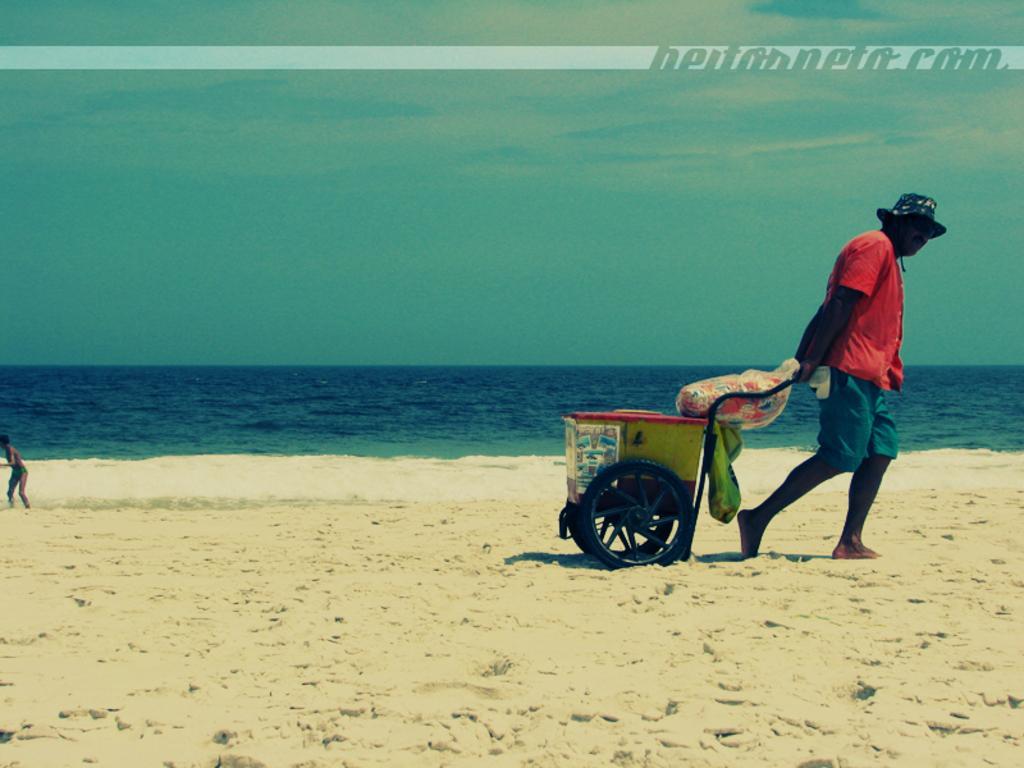Could you give a brief overview of what you see in this image? In the foreground of the picture we can see a person pulling a cart and there is sand. On the left we can see a person playing in the water. In the middle there is a water body. At the top it is text. In the top right corner we can see text. 